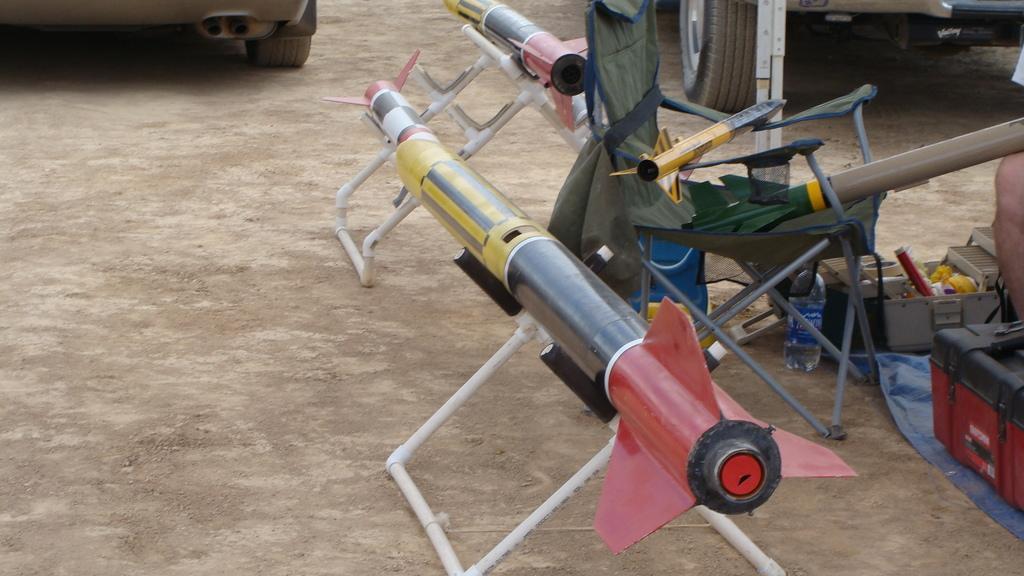Could you give a brief overview of what you see in this image? In the foreground of the picture there are rockets. On the right there are boxes and persons leg. At the top there are vehicles. In the picture there is soil. 